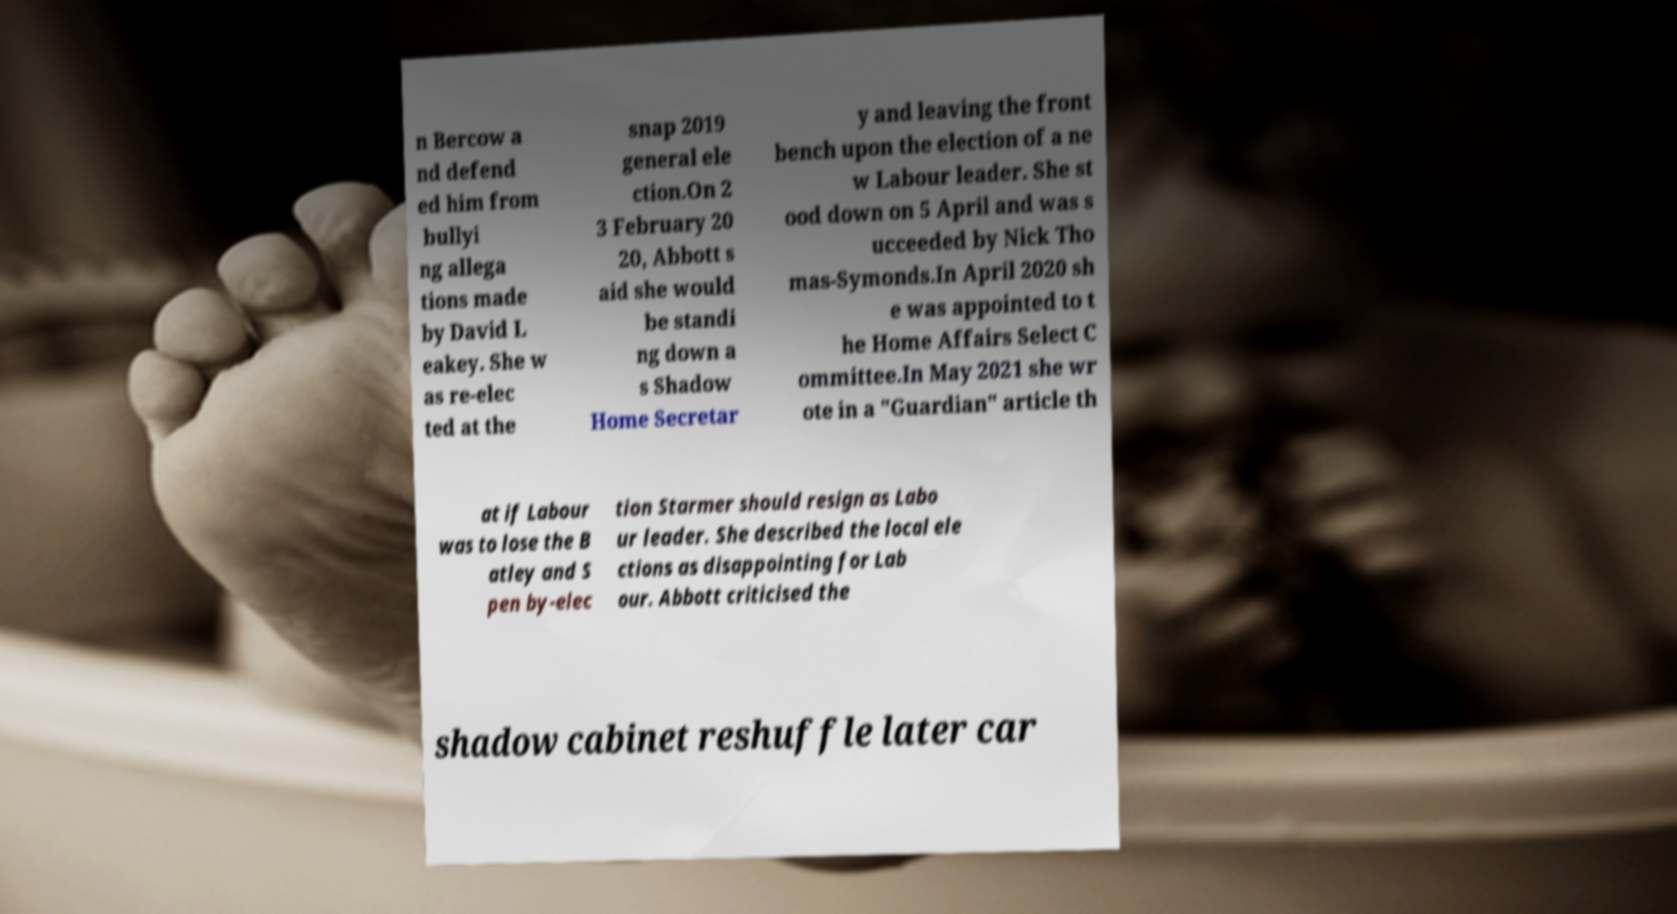Please identify and transcribe the text found in this image. n Bercow a nd defend ed him from bullyi ng allega tions made by David L eakey. She w as re-elec ted at the snap 2019 general ele ction.On 2 3 February 20 20, Abbott s aid she would be standi ng down a s Shadow Home Secretar y and leaving the front bench upon the election of a ne w Labour leader. She st ood down on 5 April and was s ucceeded by Nick Tho mas-Symonds.In April 2020 sh e was appointed to t he Home Affairs Select C ommittee.In May 2021 she wr ote in a "Guardian" article th at if Labour was to lose the B atley and S pen by-elec tion Starmer should resign as Labo ur leader. She described the local ele ctions as disappointing for Lab our. Abbott criticised the shadow cabinet reshuffle later car 